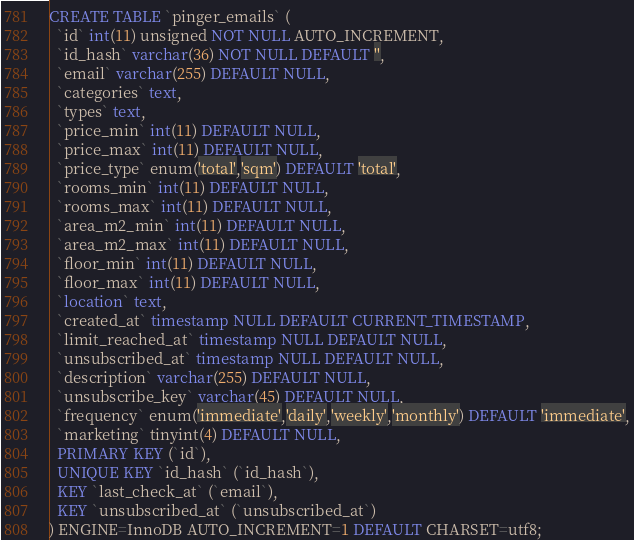Convert code to text. <code><loc_0><loc_0><loc_500><loc_500><_SQL_>CREATE TABLE `pinger_emails` (
  `id` int(11) unsigned NOT NULL AUTO_INCREMENT,
  `id_hash` varchar(36) NOT NULL DEFAULT '',
  `email` varchar(255) DEFAULT NULL,
  `categories` text,
  `types` text,
  `price_min` int(11) DEFAULT NULL,
  `price_max` int(11) DEFAULT NULL,
  `price_type` enum('total','sqm') DEFAULT 'total',
  `rooms_min` int(11) DEFAULT NULL,
  `rooms_max` int(11) DEFAULT NULL,
  `area_m2_min` int(11) DEFAULT NULL,
  `area_m2_max` int(11) DEFAULT NULL,
  `floor_min` int(11) DEFAULT NULL,
  `floor_max` int(11) DEFAULT NULL,
  `location` text,
  `created_at` timestamp NULL DEFAULT CURRENT_TIMESTAMP,
  `limit_reached_at` timestamp NULL DEFAULT NULL,
  `unsubscribed_at` timestamp NULL DEFAULT NULL,
  `description` varchar(255) DEFAULT NULL,
  `unsubscribe_key` varchar(45) DEFAULT NULL,
  `frequency` enum('immediate','daily','weekly','monthly') DEFAULT 'immediate',
  `marketing` tinyint(4) DEFAULT NULL,
  PRIMARY KEY (`id`),
  UNIQUE KEY `id_hash` (`id_hash`),
  KEY `last_check_at` (`email`),
  KEY `unsubscribed_at` (`unsubscribed_at`)
) ENGINE=InnoDB AUTO_INCREMENT=1 DEFAULT CHARSET=utf8;
</code> 